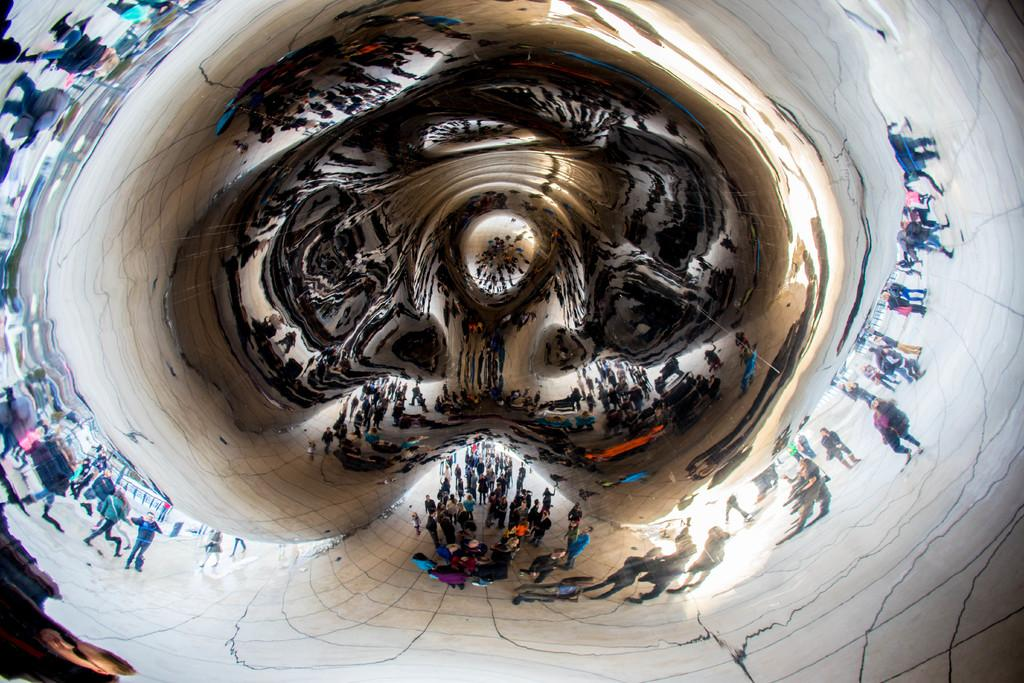What is the main subject in the image? There is a cloud gate in the image. What can be observed on the surface of the cloud gate? The cloud gate has the reflection of persons on it. What type of cactus can be seen growing near the cloud gate in the image? There is no cactus present in the image. 